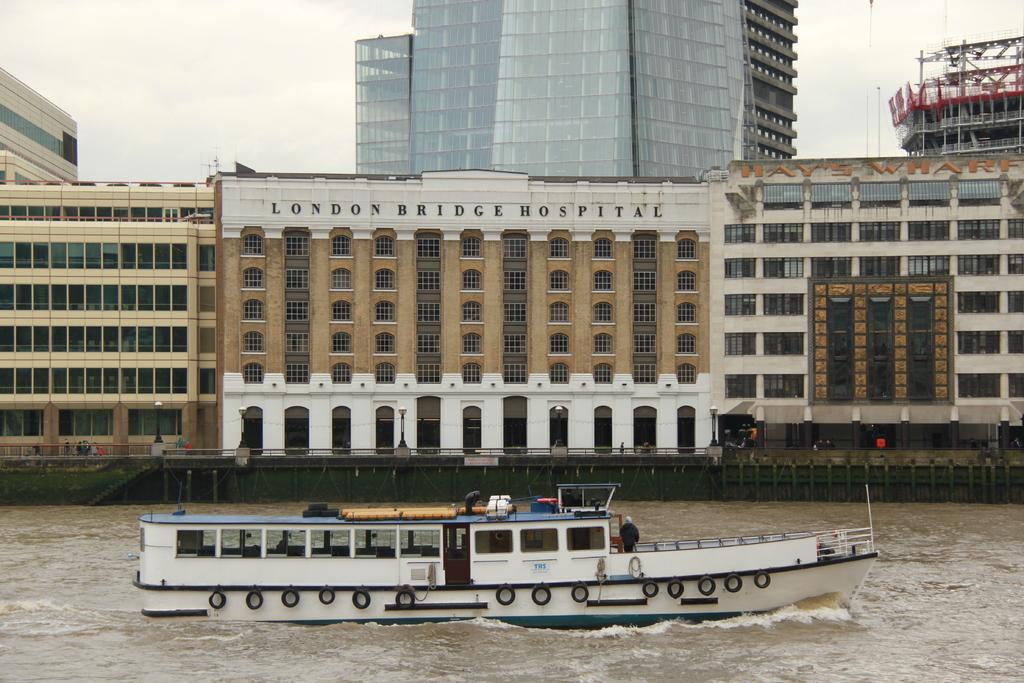What is the hospitals name?
Offer a terse response. London bridge hospital. 